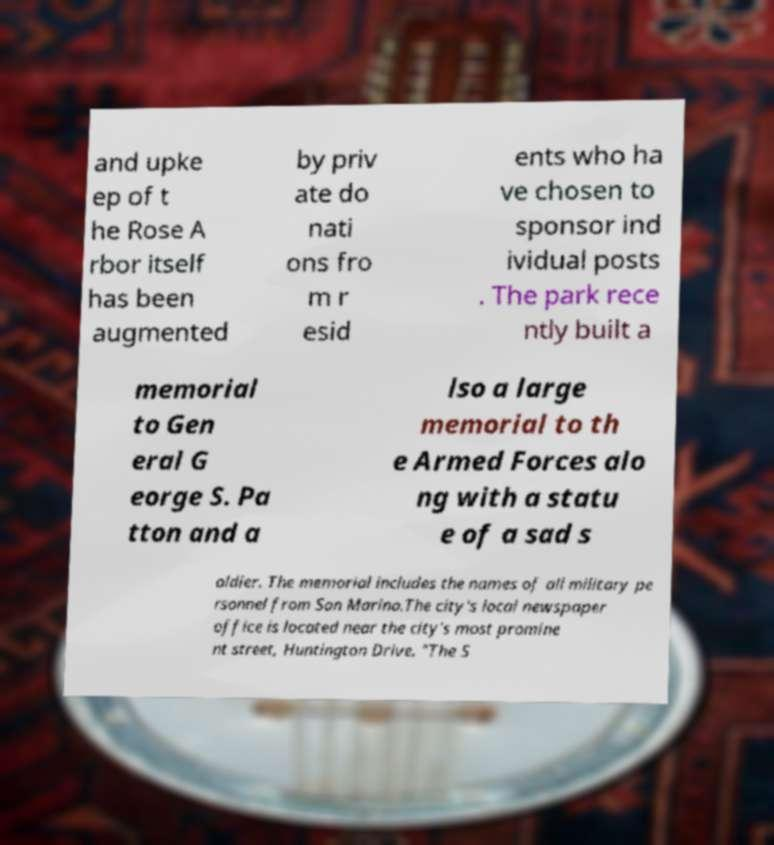Could you extract and type out the text from this image? and upke ep of t he Rose A rbor itself has been augmented by priv ate do nati ons fro m r esid ents who ha ve chosen to sponsor ind ividual posts . The park rece ntly built a memorial to Gen eral G eorge S. Pa tton and a lso a large memorial to th e Armed Forces alo ng with a statu e of a sad s oldier. The memorial includes the names of all military pe rsonnel from San Marino.The city's local newspaper office is located near the city's most promine nt street, Huntington Drive. "The S 